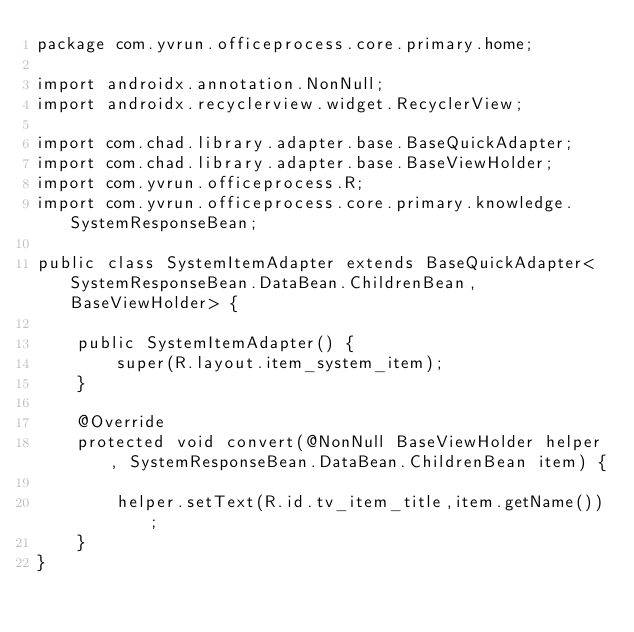Convert code to text. <code><loc_0><loc_0><loc_500><loc_500><_Java_>package com.yvrun.officeprocess.core.primary.home;

import androidx.annotation.NonNull;
import androidx.recyclerview.widget.RecyclerView;

import com.chad.library.adapter.base.BaseQuickAdapter;
import com.chad.library.adapter.base.BaseViewHolder;
import com.yvrun.officeprocess.R;
import com.yvrun.officeprocess.core.primary.knowledge.SystemResponseBean;

public class SystemItemAdapter extends BaseQuickAdapter<SystemResponseBean.DataBean.ChildrenBean, BaseViewHolder> {

    public SystemItemAdapter() {
        super(R.layout.item_system_item);
    }

    @Override
    protected void convert(@NonNull BaseViewHolder helper, SystemResponseBean.DataBean.ChildrenBean item) {

        helper.setText(R.id.tv_item_title,item.getName());
    }
}
</code> 